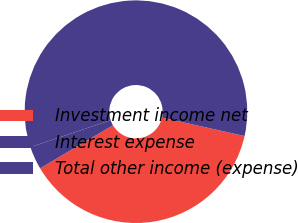<chart> <loc_0><loc_0><loc_500><loc_500><pie_chart><fcel>Investment income net<fcel>Interest expense<fcel>Total other income (expense)<nl><fcel>37.99%<fcel>3.34%<fcel>58.66%<nl></chart> 